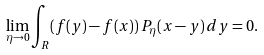Convert formula to latex. <formula><loc_0><loc_0><loc_500><loc_500>\lim _ { \eta \to 0 } \int _ { R } ( f ( y ) - f ( x ) ) \, P _ { \eta } ( x - y ) \, d y = 0 .</formula> 